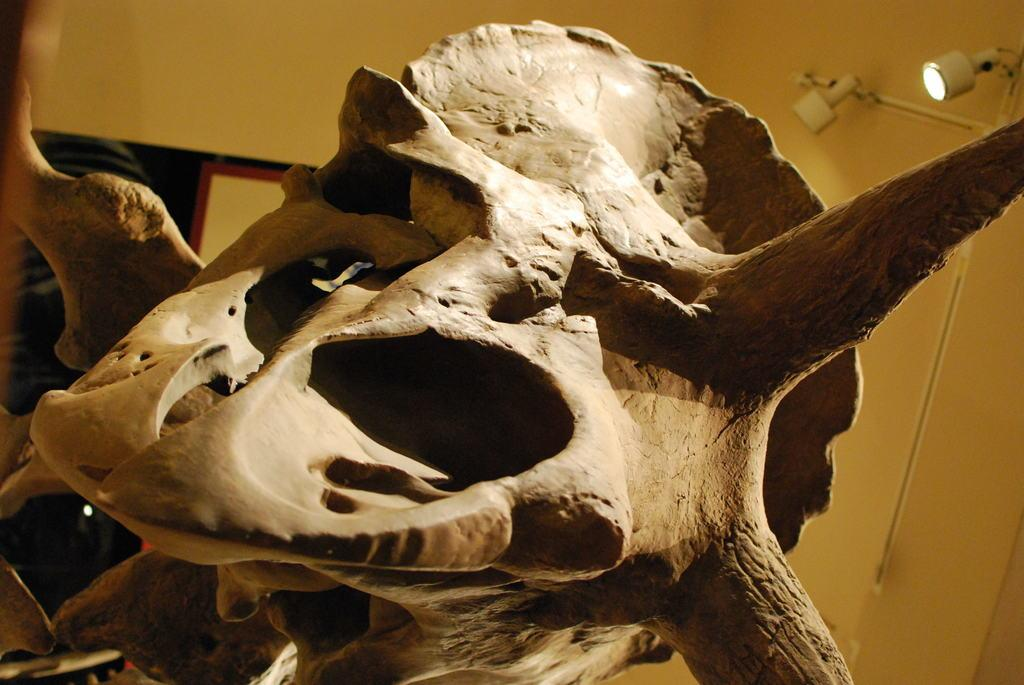What is the main subject in the center of the image? There is a structure in the center of the image. What can be seen in the background of the image? There are lights and a wall visible in the background. What type of beam is being used to burst the structure in the image? There is no beam or bursting action present in the image; it features a structure with lights and a wall in the background. 